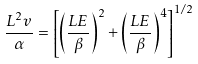<formula> <loc_0><loc_0><loc_500><loc_500>\frac { L ^ { 2 } v } { \alpha } = \left [ \left ( \frac { L E } { \beta } \right ) ^ { 2 } + \left ( \frac { L E } { \beta } \right ) ^ { 4 } \right ] ^ { 1 / 2 }</formula> 